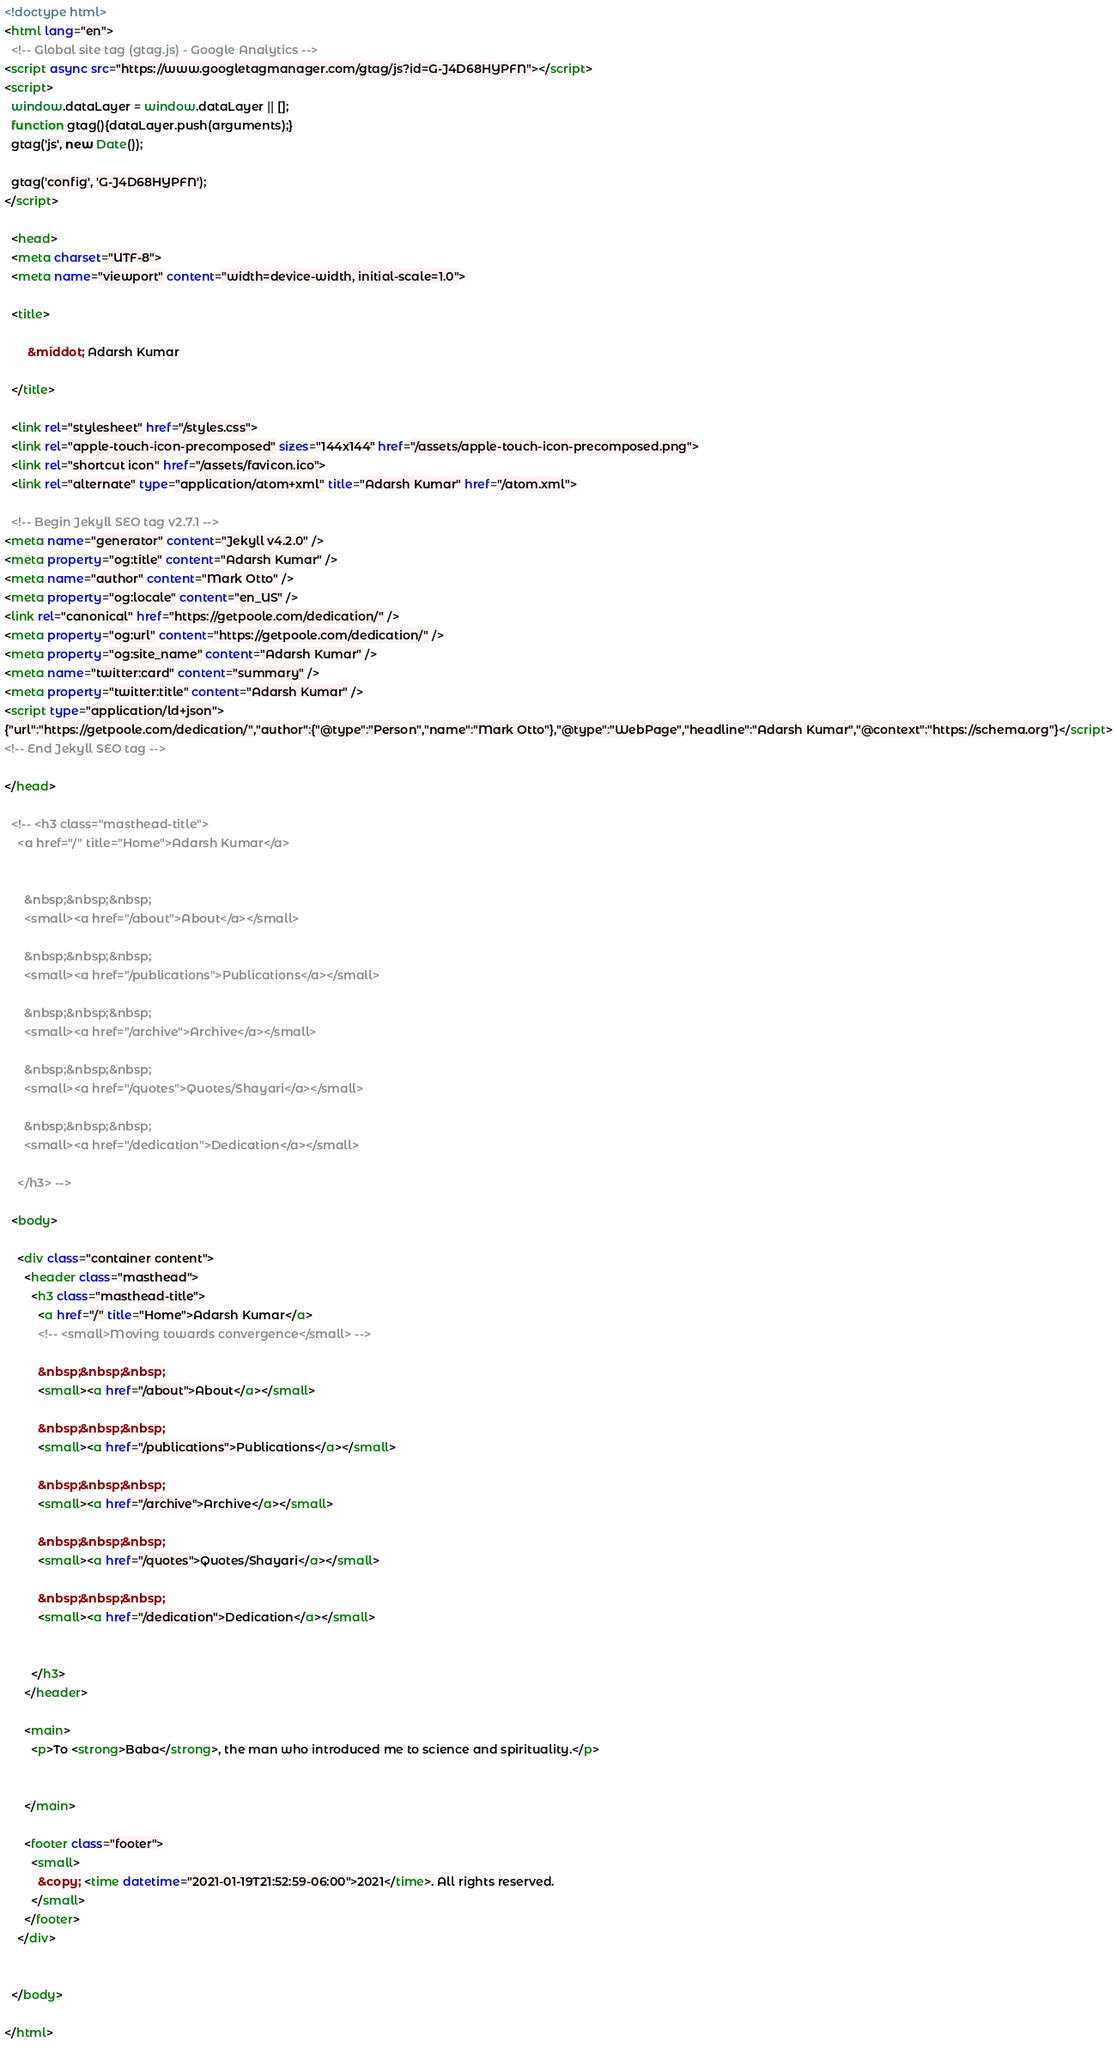<code> <loc_0><loc_0><loc_500><loc_500><_HTML_><!doctype html>
<html lang="en">
  <!-- Global site tag (gtag.js) - Google Analytics -->
<script async src="https://www.googletagmanager.com/gtag/js?id=G-J4D68HYPFN"></script>
<script>
  window.dataLayer = window.dataLayer || [];
  function gtag(){dataLayer.push(arguments);}
  gtag('js', new Date());

  gtag('config', 'G-J4D68HYPFN');
</script>

  <head>
  <meta charset="UTF-8">
  <meta name="viewport" content="width=device-width, initial-scale=1.0">

  <title>
    
       &middot; Adarsh Kumar
    
  </title>

  <link rel="stylesheet" href="/styles.css">
  <link rel="apple-touch-icon-precomposed" sizes="144x144" href="/assets/apple-touch-icon-precomposed.png">
  <link rel="shortcut icon" href="/assets/favicon.ico">
  <link rel="alternate" type="application/atom+xml" title="Adarsh Kumar" href="/atom.xml">

  <!-- Begin Jekyll SEO tag v2.7.1 -->
<meta name="generator" content="Jekyll v4.2.0" />
<meta property="og:title" content="Adarsh Kumar" />
<meta name="author" content="Mark Otto" />
<meta property="og:locale" content="en_US" />
<link rel="canonical" href="https://getpoole.com/dedication/" />
<meta property="og:url" content="https://getpoole.com/dedication/" />
<meta property="og:site_name" content="Adarsh Kumar" />
<meta name="twitter:card" content="summary" />
<meta property="twitter:title" content="Adarsh Kumar" />
<script type="application/ld+json">
{"url":"https://getpoole.com/dedication/","author":{"@type":"Person","name":"Mark Otto"},"@type":"WebPage","headline":"Adarsh Kumar","@context":"https://schema.org"}</script>
<!-- End Jekyll SEO tag -->

</head>

  <!-- <h3 class="masthead-title">
    <a href="/" title="Home">Adarsh Kumar</a>
    
    
      &nbsp;&nbsp;&nbsp;
      <small><a href="/about">About</a></small>
    
      &nbsp;&nbsp;&nbsp;
      <small><a href="/publications">Publications</a></small>
    
      &nbsp;&nbsp;&nbsp;
      <small><a href="/archive">Archive</a></small>
    
      &nbsp;&nbsp;&nbsp;
      <small><a href="/quotes">Quotes/Shayari</a></small>
    
      &nbsp;&nbsp;&nbsp;
      <small><a href="/dedication">Dedication</a></small>
    
    </h3> -->

  <body>

    <div class="container content">
      <header class="masthead">
        <h3 class="masthead-title">
          <a href="/" title="Home">Adarsh Kumar</a>
          <!-- <small>Moving towards convergence</small> -->
          
          &nbsp;&nbsp;&nbsp;
          <small><a href="/about">About</a></small>
          
          &nbsp;&nbsp;&nbsp;
          <small><a href="/publications">Publications</a></small>
          
          &nbsp;&nbsp;&nbsp;
          <small><a href="/archive">Archive</a></small>
          
          &nbsp;&nbsp;&nbsp;
          <small><a href="/quotes">Quotes/Shayari</a></small>
          
          &nbsp;&nbsp;&nbsp;
          <small><a href="/dedication">Dedication</a></small>
          

        </h3>
      </header>

      <main>
        <p>To <strong>Baba</strong>, the man who introduced me to science and spirituality.</p>


      </main>

      <footer class="footer">
        <small>
          &copy; <time datetime="2021-01-19T21:52:59-06:00">2021</time>. All rights reserved.
        </small>
      </footer>
    </div>

    
  </body>

</html>


</code> 